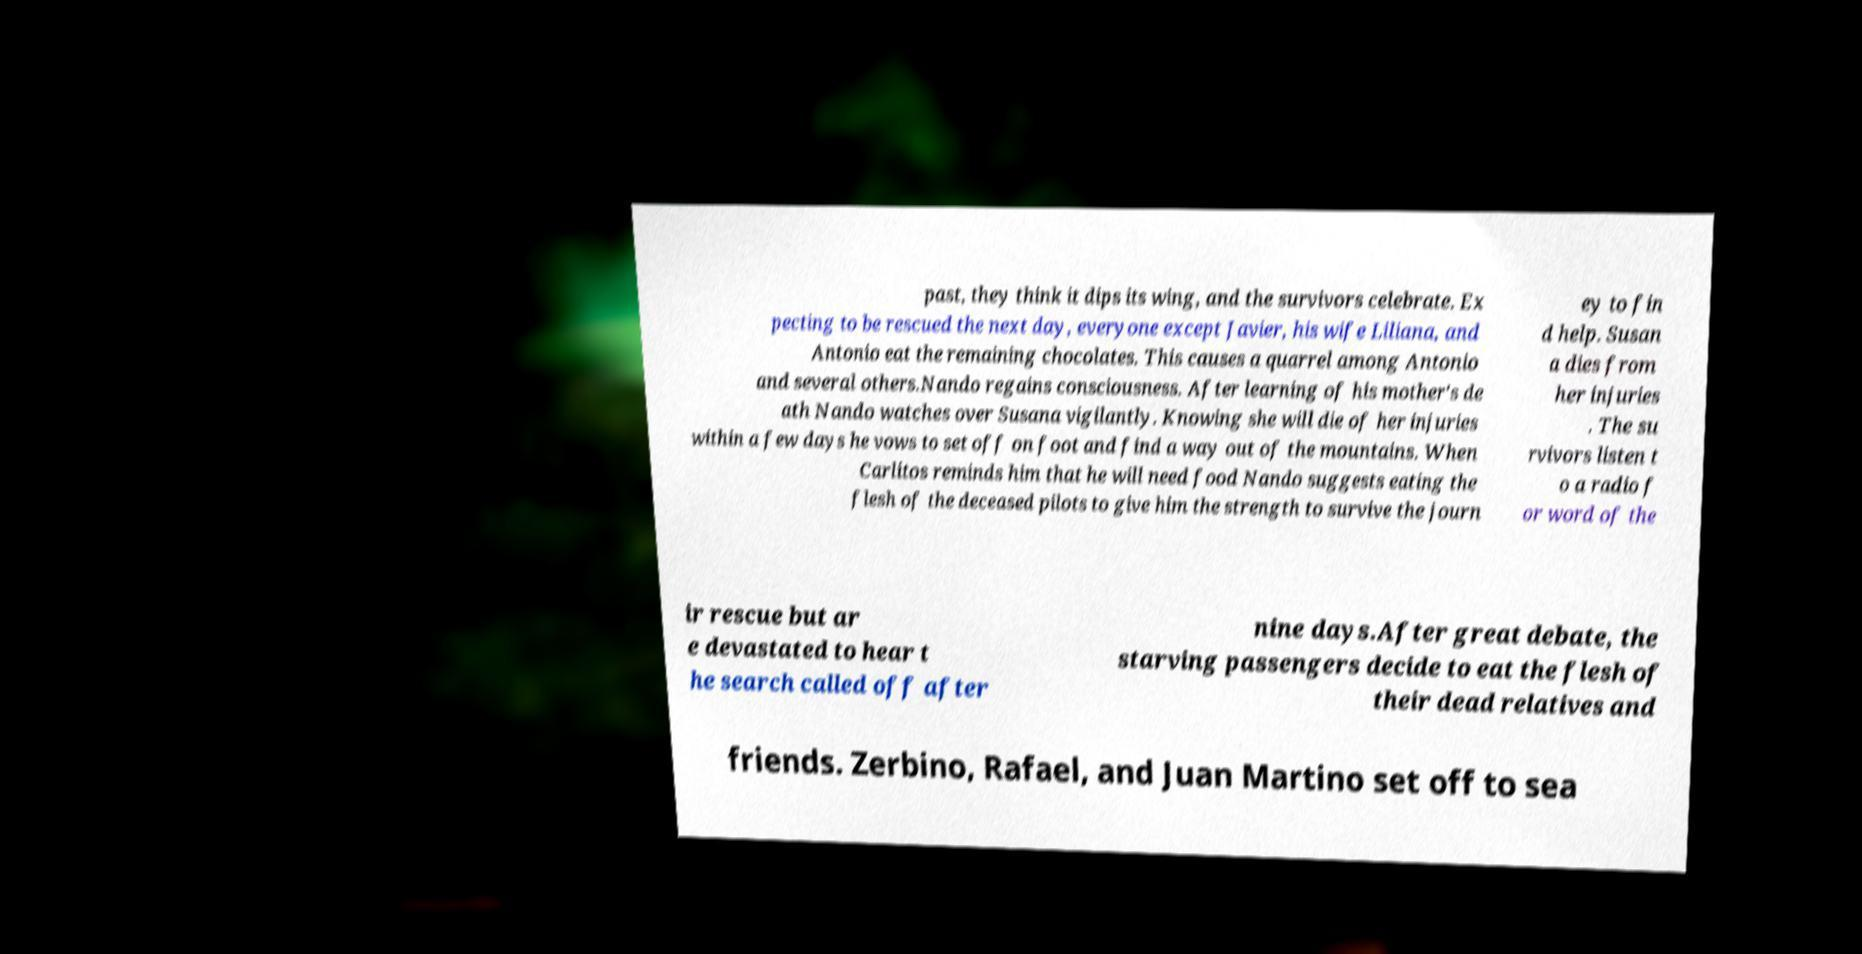Please read and relay the text visible in this image. What does it say? past, they think it dips its wing, and the survivors celebrate. Ex pecting to be rescued the next day, everyone except Javier, his wife Liliana, and Antonio eat the remaining chocolates. This causes a quarrel among Antonio and several others.Nando regains consciousness. After learning of his mother's de ath Nando watches over Susana vigilantly. Knowing she will die of her injuries within a few days he vows to set off on foot and find a way out of the mountains. When Carlitos reminds him that he will need food Nando suggests eating the flesh of the deceased pilots to give him the strength to survive the journ ey to fin d help. Susan a dies from her injuries . The su rvivors listen t o a radio f or word of the ir rescue but ar e devastated to hear t he search called off after nine days.After great debate, the starving passengers decide to eat the flesh of their dead relatives and friends. Zerbino, Rafael, and Juan Martino set off to sea 